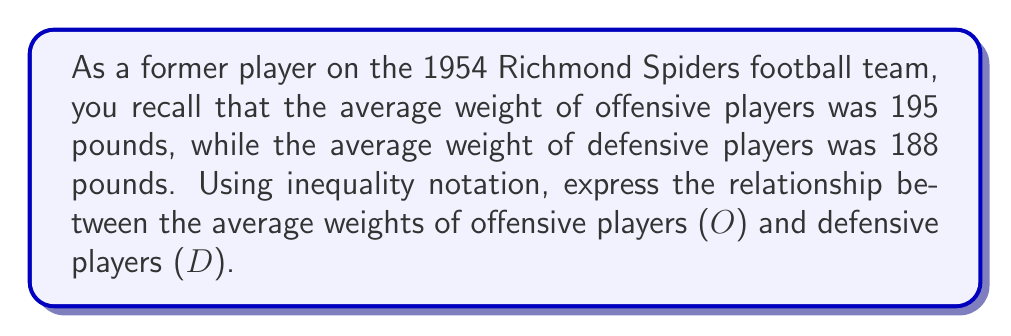Can you answer this question? To solve this problem, we need to compare the given average weights using inequality notation:

1. Average weight of offensive players (O) = 195 pounds
2. Average weight of defensive players (D) = 188 pounds

Since 195 is greater than 188, we can express this relationship using the "greater than" symbol (>).

In mathematical notation, we write:

$$O > D$$

This inequality states that the average weight of offensive players is greater than the average weight of defensive players.

We can also express this relationship with actual values:

$$195 > 188$$

Both forms of the inequality are correct and represent the same relationship between the average weights of offensive and defensive players.
Answer: $O > D$ or $195 > 188$ 